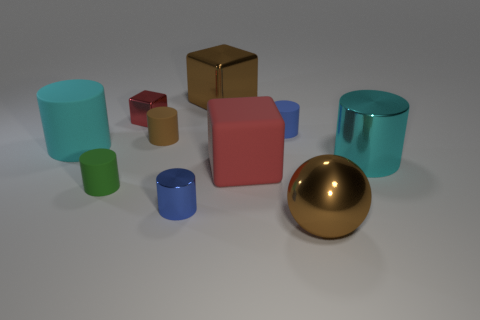What number of things are either things that are left of the big red object or big blue cylinders?
Offer a terse response. 6. What size is the brown ball that is the same material as the tiny cube?
Provide a succinct answer. Large. Are there more tiny red things on the left side of the large shiny cylinder than tiny yellow matte balls?
Keep it short and to the point. Yes. Is the shape of the big red object the same as the small metallic thing behind the big cyan shiny cylinder?
Your answer should be compact. Yes. What number of small objects are blue objects or spheres?
Ensure brevity in your answer.  2. What size is the shiny cube that is the same color as the big ball?
Make the answer very short. Large. There is a big thing that is to the right of the big brown shiny thing that is in front of the brown matte object; what is its color?
Offer a terse response. Cyan. Do the brown cube and the cylinder that is on the right side of the large brown ball have the same material?
Offer a terse response. Yes. There is a red cube in front of the tiny metallic block; what material is it?
Keep it short and to the point. Rubber. Are there an equal number of large brown balls behind the brown metal ball and green rubber cylinders?
Offer a very short reply. No. 